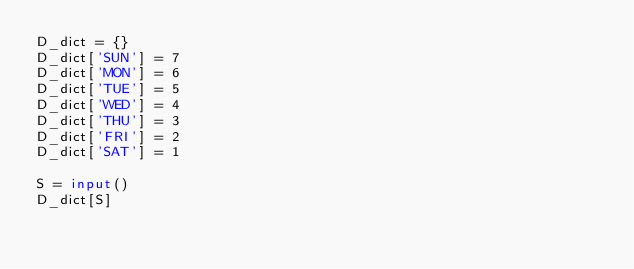Convert code to text. <code><loc_0><loc_0><loc_500><loc_500><_Python_>D_dict = {}
D_dict['SUN'] = 7
D_dict['MON'] = 6
D_dict['TUE'] = 5
D_dict['WED'] = 4
D_dict['THU'] = 3
D_dict['FRI'] = 2
D_dict['SAT'] = 1

S = input()
D_dict[S]</code> 